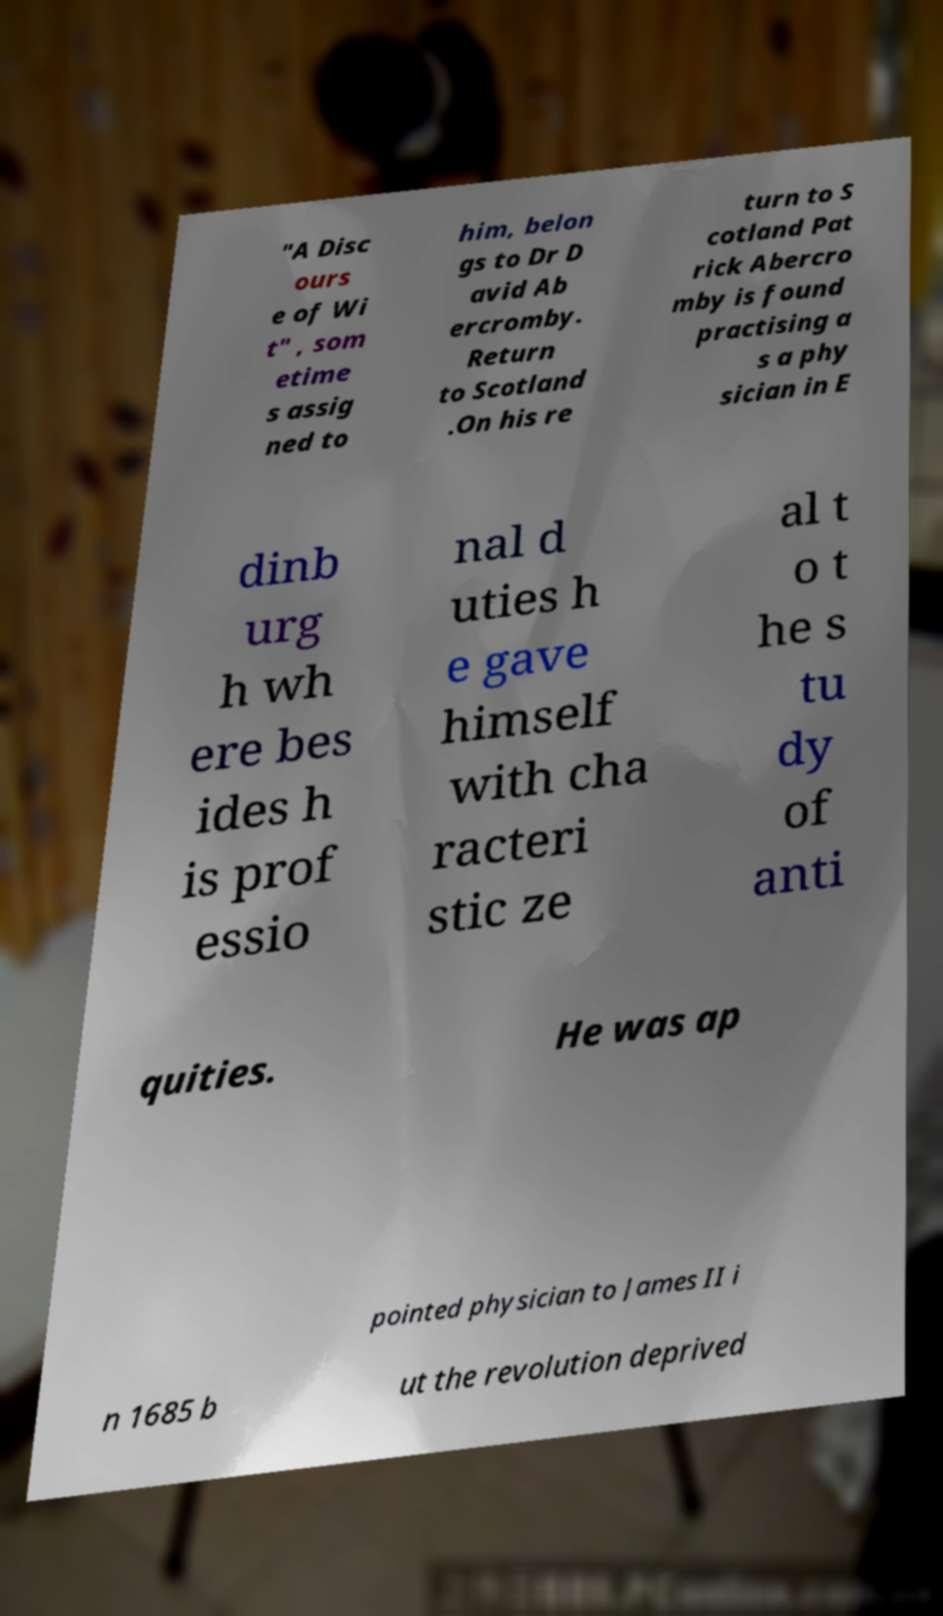For documentation purposes, I need the text within this image transcribed. Could you provide that? "A Disc ours e of Wi t" , som etime s assig ned to him, belon gs to Dr D avid Ab ercromby. Return to Scotland .On his re turn to S cotland Pat rick Abercro mby is found practising a s a phy sician in E dinb urg h wh ere bes ides h is prof essio nal d uties h e gave himself with cha racteri stic ze al t o t he s tu dy of anti quities. He was ap pointed physician to James II i n 1685 b ut the revolution deprived 